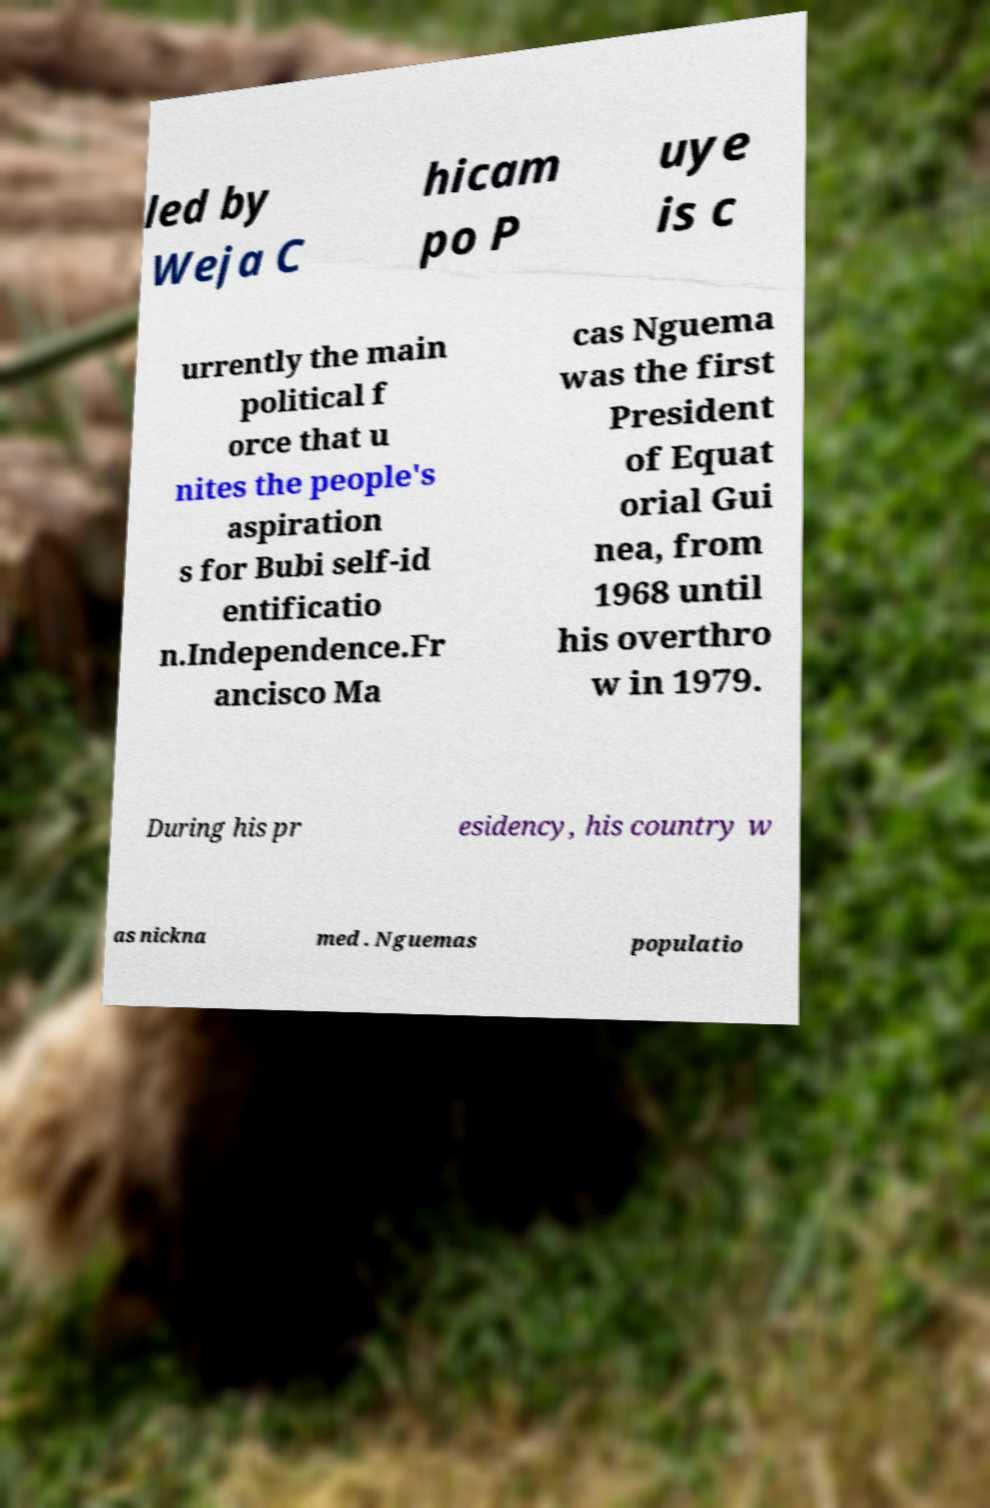Please read and relay the text visible in this image. What does it say? led by Weja C hicam po P uye is c urrently the main political f orce that u nites the people's aspiration s for Bubi self-id entificatio n.Independence.Fr ancisco Ma cas Nguema was the first President of Equat orial Gui nea, from 1968 until his overthro w in 1979. During his pr esidency, his country w as nickna med . Nguemas populatio 